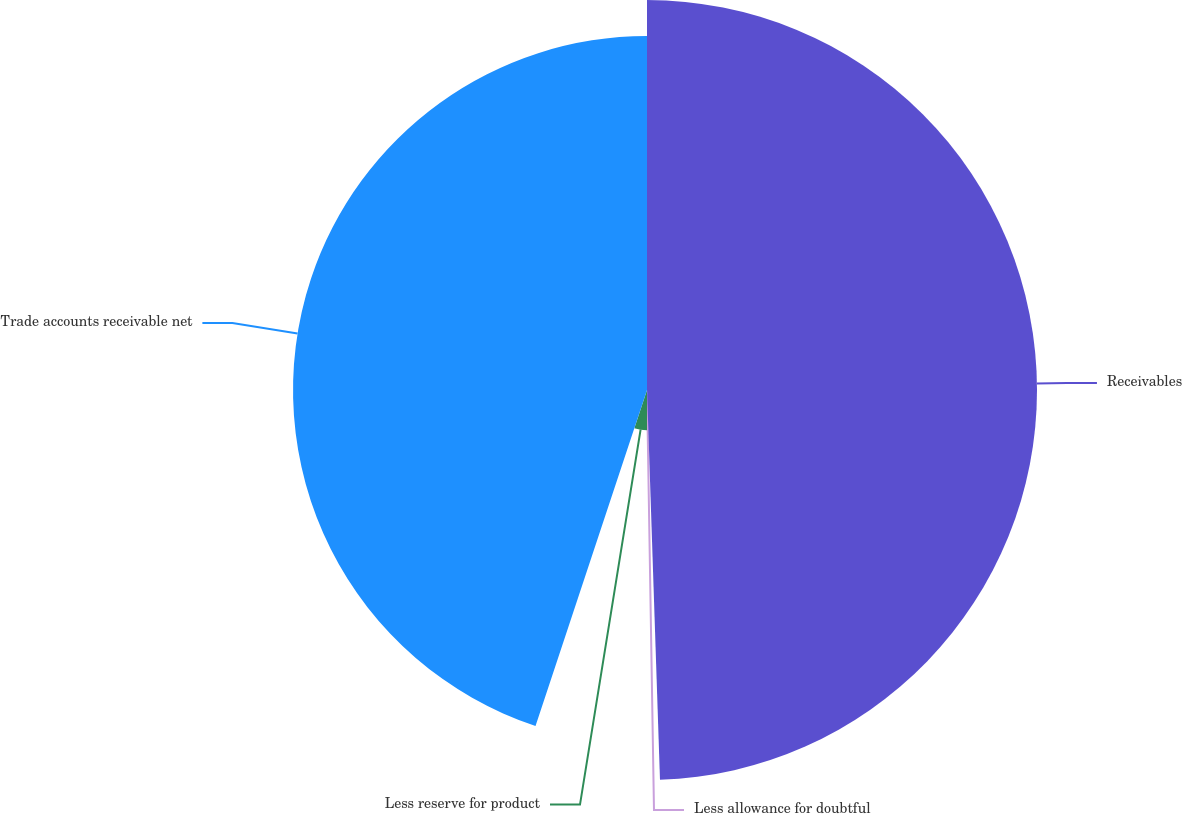Convert chart to OTSL. <chart><loc_0><loc_0><loc_500><loc_500><pie_chart><fcel>Receivables<fcel>Less allowance for doubtful<fcel>Less reserve for product<fcel>Trade accounts receivable net<nl><fcel>49.47%<fcel>0.53%<fcel>5.1%<fcel>44.9%<nl></chart> 